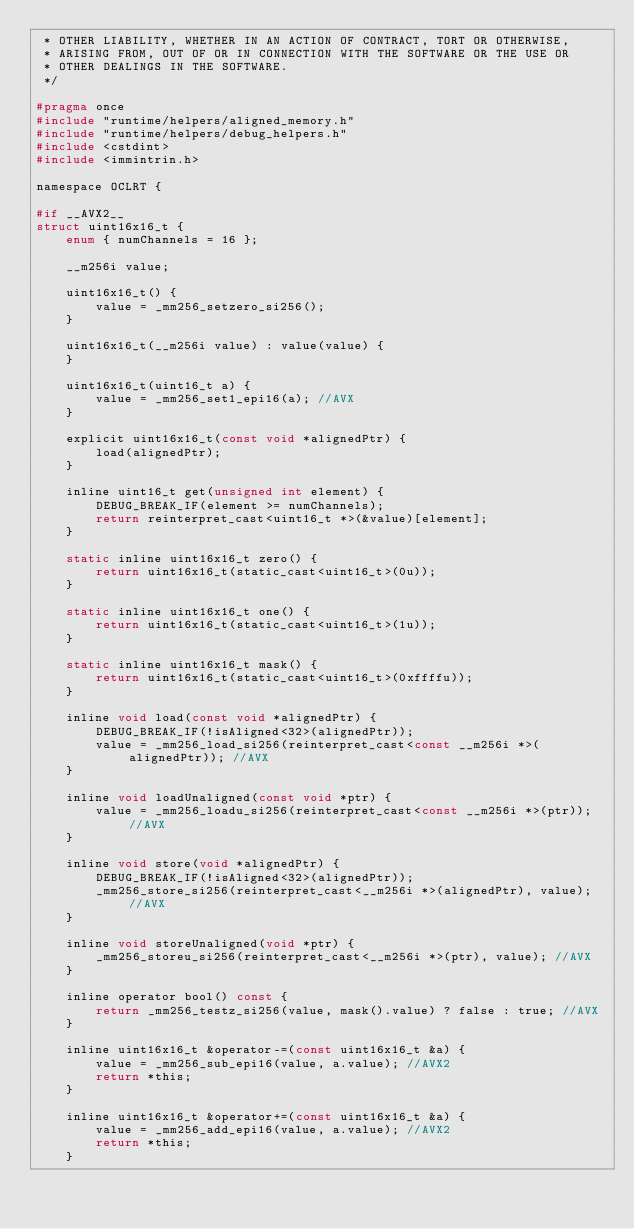<code> <loc_0><loc_0><loc_500><loc_500><_C_> * OTHER LIABILITY, WHETHER IN AN ACTION OF CONTRACT, TORT OR OTHERWISE,
 * ARISING FROM, OUT OF OR IN CONNECTION WITH THE SOFTWARE OR THE USE OR
 * OTHER DEALINGS IN THE SOFTWARE.
 */

#pragma once
#include "runtime/helpers/aligned_memory.h"
#include "runtime/helpers/debug_helpers.h"
#include <cstdint>
#include <immintrin.h>

namespace OCLRT {

#if __AVX2__
struct uint16x16_t {
    enum { numChannels = 16 };

    __m256i value;

    uint16x16_t() {
        value = _mm256_setzero_si256();
    }

    uint16x16_t(__m256i value) : value(value) {
    }

    uint16x16_t(uint16_t a) {
        value = _mm256_set1_epi16(a); //AVX
    }

    explicit uint16x16_t(const void *alignedPtr) {
        load(alignedPtr);
    }

    inline uint16_t get(unsigned int element) {
        DEBUG_BREAK_IF(element >= numChannels);
        return reinterpret_cast<uint16_t *>(&value)[element];
    }

    static inline uint16x16_t zero() {
        return uint16x16_t(static_cast<uint16_t>(0u));
    }

    static inline uint16x16_t one() {
        return uint16x16_t(static_cast<uint16_t>(1u));
    }

    static inline uint16x16_t mask() {
        return uint16x16_t(static_cast<uint16_t>(0xffffu));
    }

    inline void load(const void *alignedPtr) {
        DEBUG_BREAK_IF(!isAligned<32>(alignedPtr));
        value = _mm256_load_si256(reinterpret_cast<const __m256i *>(alignedPtr)); //AVX
    }

    inline void loadUnaligned(const void *ptr) {
        value = _mm256_loadu_si256(reinterpret_cast<const __m256i *>(ptr)); //AVX
    }

    inline void store(void *alignedPtr) {
        DEBUG_BREAK_IF(!isAligned<32>(alignedPtr));
        _mm256_store_si256(reinterpret_cast<__m256i *>(alignedPtr), value); //AVX
    }

    inline void storeUnaligned(void *ptr) {
        _mm256_storeu_si256(reinterpret_cast<__m256i *>(ptr), value); //AVX
    }

    inline operator bool() const {
        return _mm256_testz_si256(value, mask().value) ? false : true; //AVX
    }

    inline uint16x16_t &operator-=(const uint16x16_t &a) {
        value = _mm256_sub_epi16(value, a.value); //AVX2
        return *this;
    }

    inline uint16x16_t &operator+=(const uint16x16_t &a) {
        value = _mm256_add_epi16(value, a.value); //AVX2
        return *this;
    }
</code> 